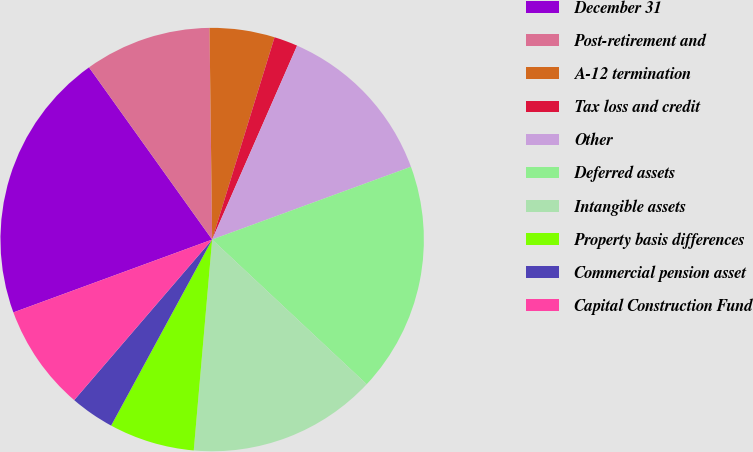Convert chart. <chart><loc_0><loc_0><loc_500><loc_500><pie_chart><fcel>December 31<fcel>Post-retirement and<fcel>A-12 termination<fcel>Tax loss and credit<fcel>Other<fcel>Deferred assets<fcel>Intangible assets<fcel>Property basis differences<fcel>Commercial pension asset<fcel>Capital Construction Fund<nl><fcel>20.71%<fcel>9.68%<fcel>4.96%<fcel>1.81%<fcel>12.84%<fcel>17.56%<fcel>14.41%<fcel>6.53%<fcel>3.38%<fcel>8.11%<nl></chart> 